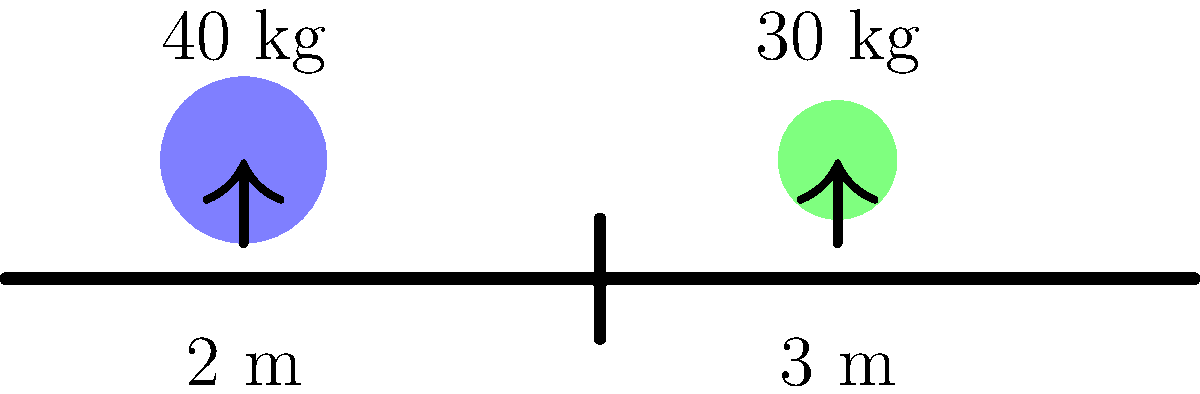As a nanny, you're supervising two children on a seesaw at the playground. The heavier child weighs 40 kg and sits 2 meters from the pivot point, while the lighter child weighs 30 kg. If the seesaw is perfectly balanced, how far from the pivot point should the lighter child sit? To solve this problem, we'll use the principle of moments, which states that for a balanced seesaw, the sum of clockwise moments equals the sum of counterclockwise moments.

Step 1: Identify the given information
- Child 1: mass (m₁) = 40 kg, distance from pivot (d₁) = 2 m
- Child 2: mass (m₂) = 30 kg, distance from pivot (d₂) = unknown

Step 2: Set up the equation for balanced moments
$$(m₁ \times d₁) = (m₂ \times d₂)$$

Step 3: Substitute the known values
$$(40 \text{ kg} \times 2 \text{ m}) = (30 \text{ kg} \times d₂)$$

Step 4: Simplify the left side of the equation
$$80 \text{ kg⋅m} = 30 \text{ kg} \times d₂$$

Step 5: Solve for d₂
$$d₂ = \frac{80 \text{ kg⋅m}}{30 \text{ kg}} = \frac{8}{3} \text{ m} = 2.67 \text{ m}$$

Therefore, the lighter child should sit 2.67 meters from the pivot point to balance the seesaw.
Answer: 2.67 meters 